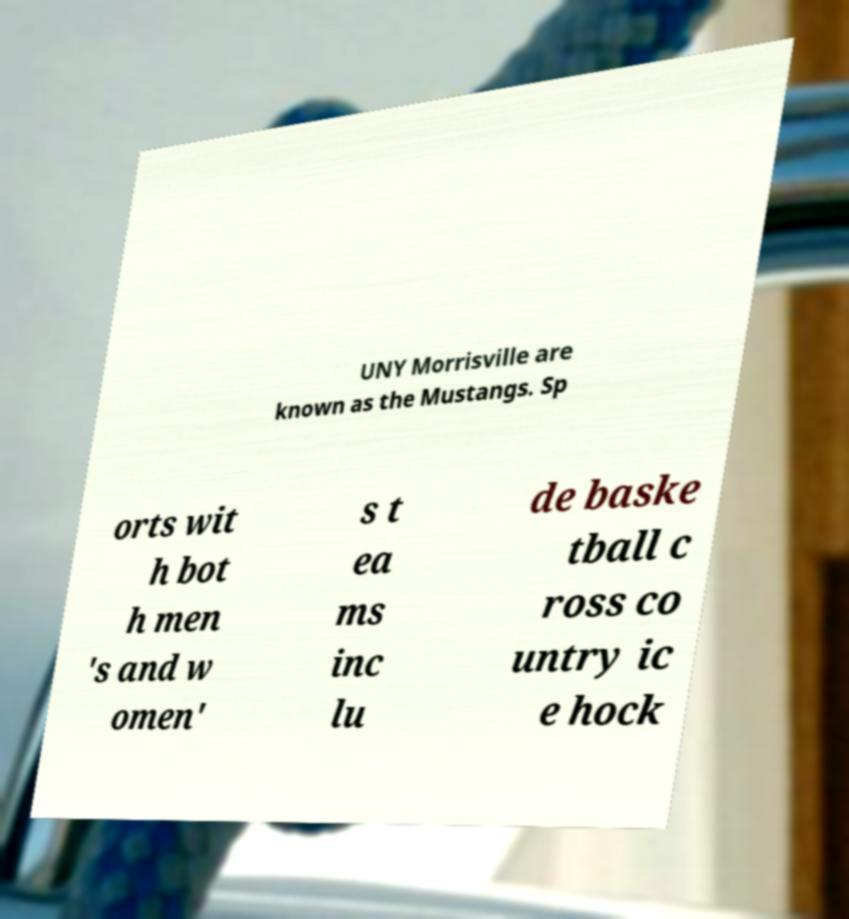Could you assist in decoding the text presented in this image and type it out clearly? UNY Morrisville are known as the Mustangs. Sp orts wit h bot h men 's and w omen' s t ea ms inc lu de baske tball c ross co untry ic e hock 